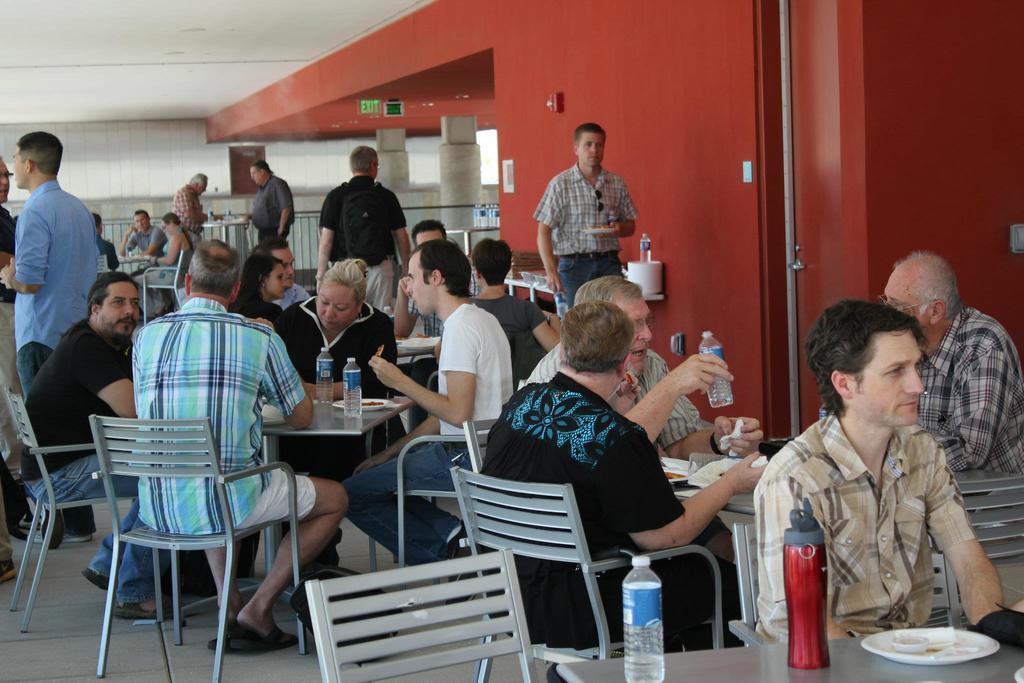Can you describe this image briefly? This image is taken inside a room. In this image there are many people, few are sitting on the chairs and few are standing. In the right side of the image a man is sitting on the chair and in front of him there is a table on top of it there is a water bottle with water, a plate on it. In the background there is a wall and pillars with railing. At the top of the image there is a ceiling. In the left side of the image a man is sitting on the chair and another man is standing. 